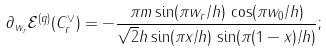<formula> <loc_0><loc_0><loc_500><loc_500>\partial _ { w _ { r } } \mathcal { E } ^ { ( q ) } ( C _ { r } ^ { \vee } ) = - \frac { \pi m \sin ( \pi w _ { r } / h ) \, \cos ( \pi w _ { 0 } / h ) } { \sqrt { 2 } h \sin ( \pi x / h ) \, \sin ( \pi ( 1 - x ) / h ) } ;</formula> 